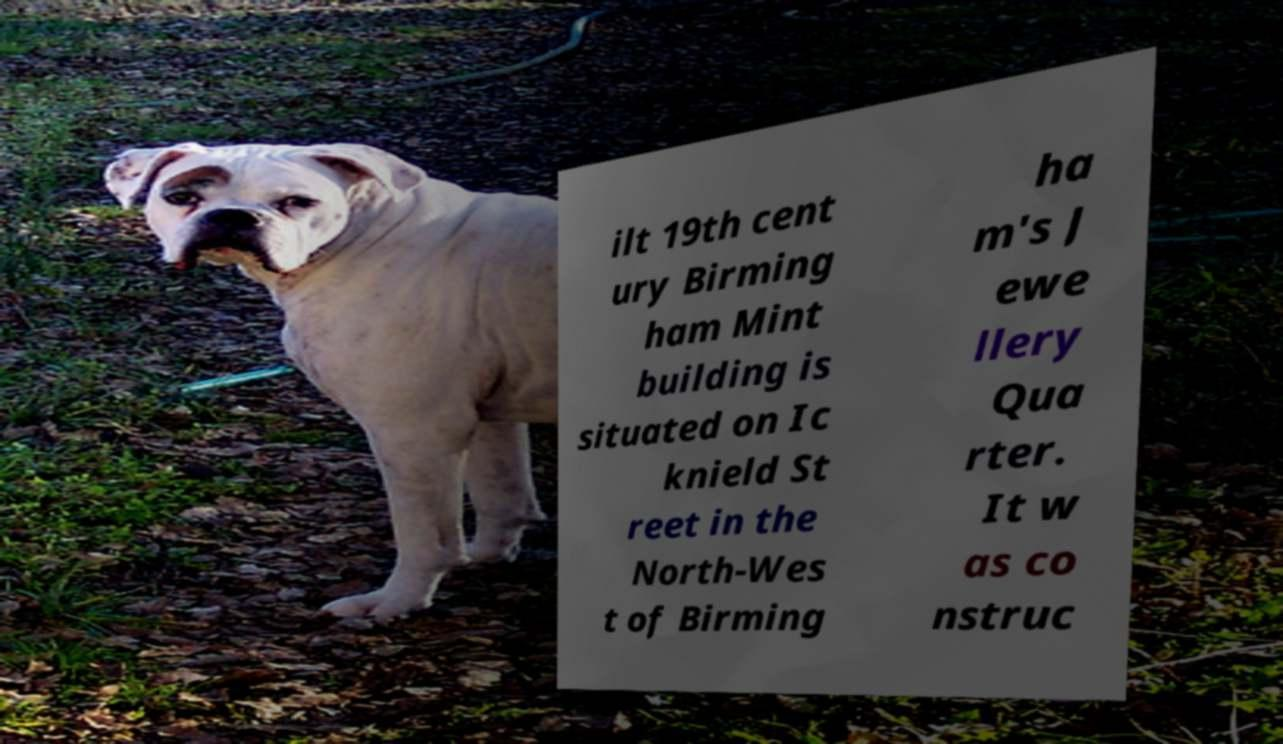For documentation purposes, I need the text within this image transcribed. Could you provide that? ilt 19th cent ury Birming ham Mint building is situated on Ic knield St reet in the North-Wes t of Birming ha m's J ewe llery Qua rter. It w as co nstruc 